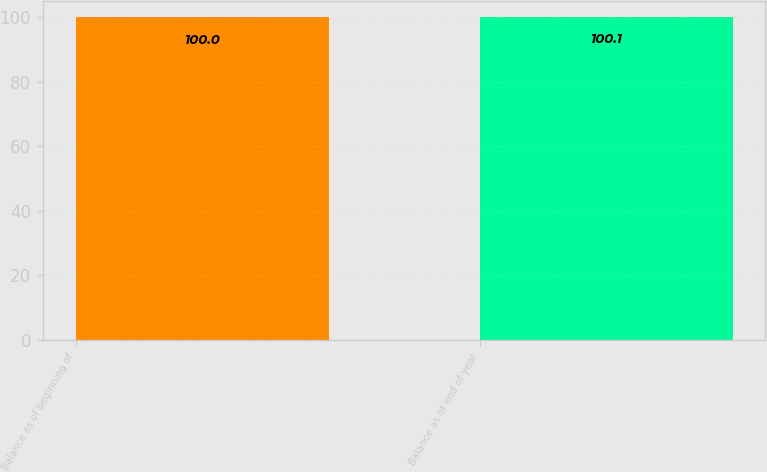Convert chart to OTSL. <chart><loc_0><loc_0><loc_500><loc_500><bar_chart><fcel>Balance as of beginning of<fcel>Balance as of end of year<nl><fcel>100<fcel>100.1<nl></chart> 